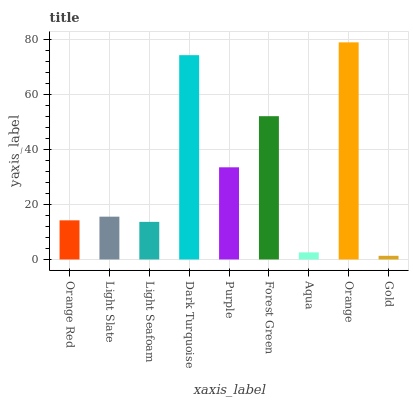Is Light Slate the minimum?
Answer yes or no. No. Is Light Slate the maximum?
Answer yes or no. No. Is Light Slate greater than Orange Red?
Answer yes or no. Yes. Is Orange Red less than Light Slate?
Answer yes or no. Yes. Is Orange Red greater than Light Slate?
Answer yes or no. No. Is Light Slate less than Orange Red?
Answer yes or no. No. Is Light Slate the high median?
Answer yes or no. Yes. Is Light Slate the low median?
Answer yes or no. Yes. Is Purple the high median?
Answer yes or no. No. Is Dark Turquoise the low median?
Answer yes or no. No. 